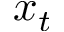Convert formula to latex. <formula><loc_0><loc_0><loc_500><loc_500>x _ { t }</formula> 